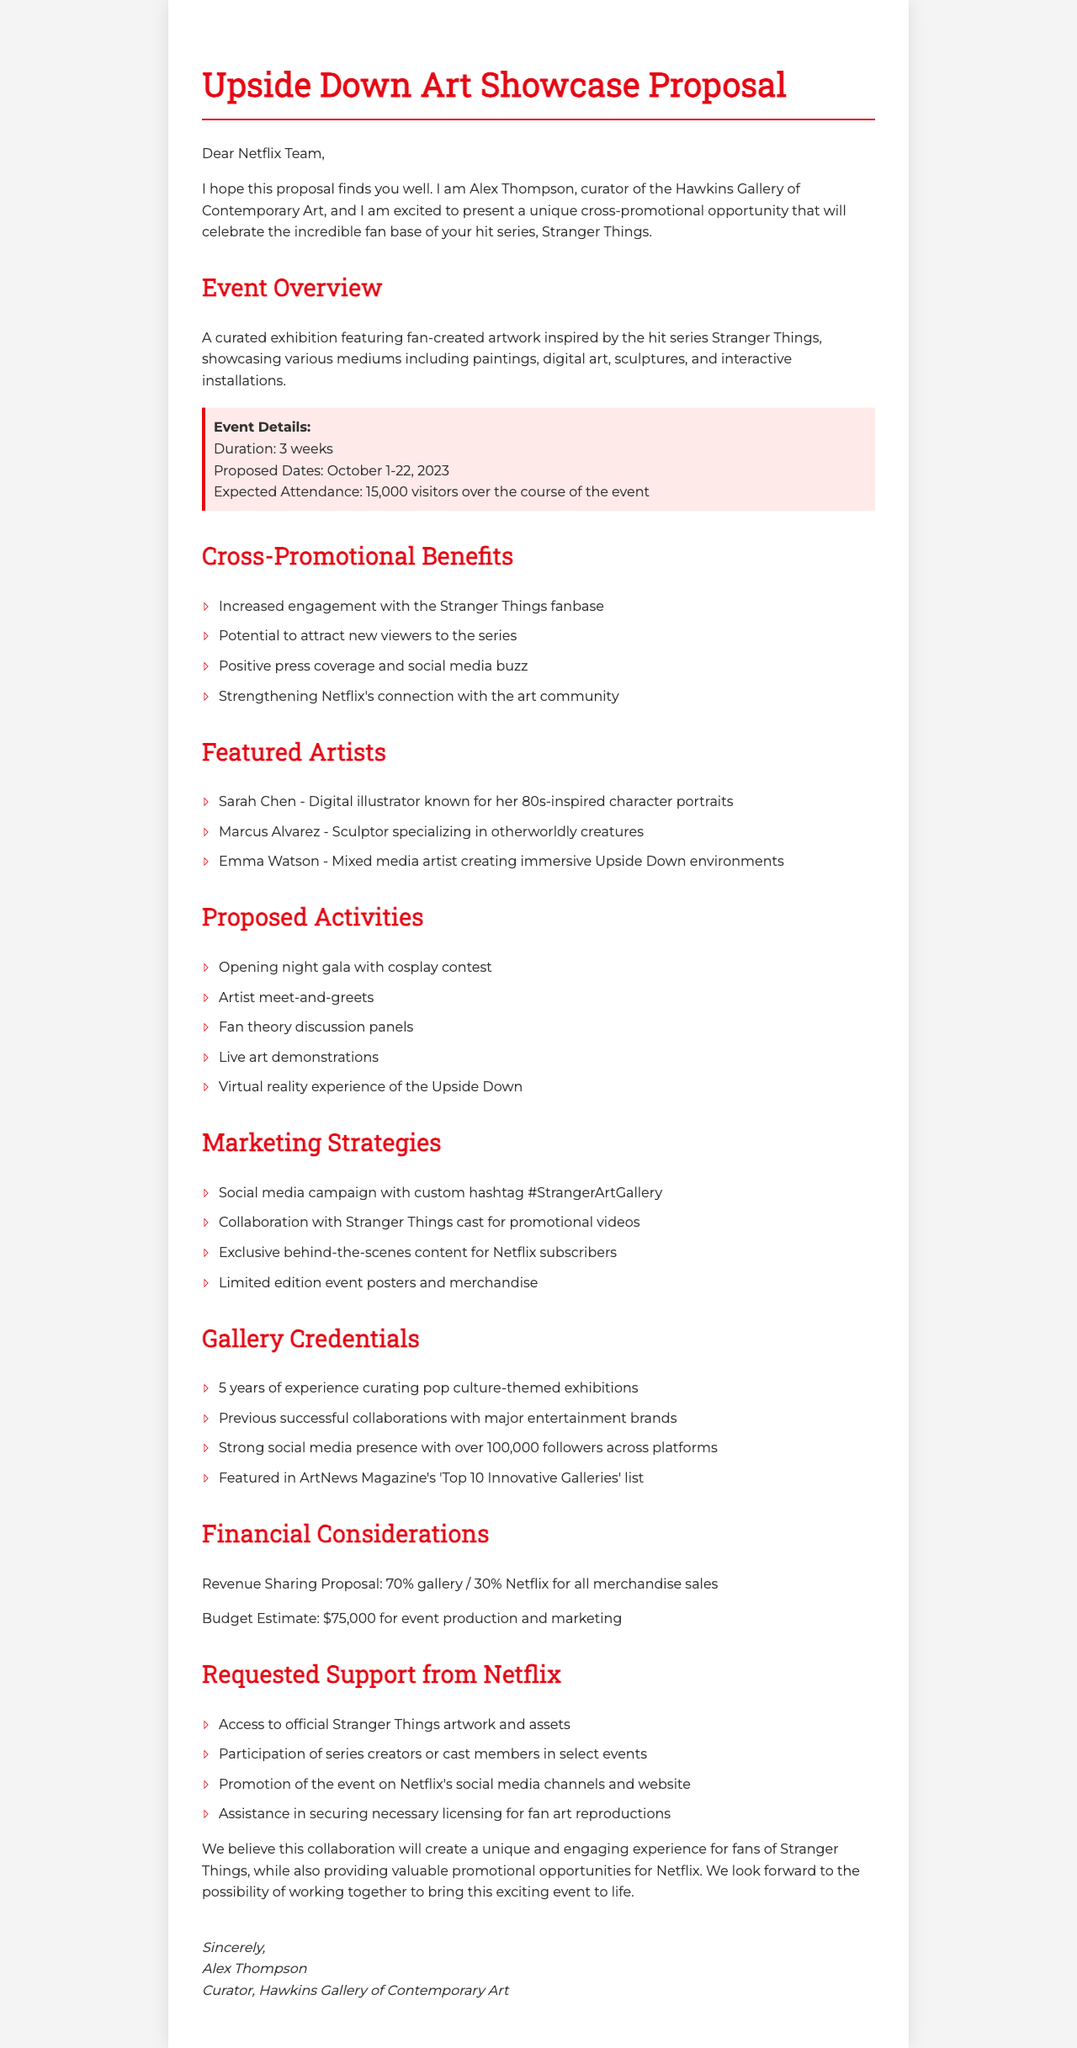What is the event name? The event name is explicitly mentioned in the document, which is "Upside Down Art Showcase".
Answer: Upside Down Art Showcase Who is the curator of the gallery? The document states the name of the curator as "Alex Thompson".
Answer: Alex Thompson What are the proposed dates for the event? The proposed dates are directly listed in the document as "October 1-22, 2023".
Answer: October 1-22, 2023 How many featured artists are mentioned? The discussion of featured artists indicates there are three specific artists listed in the document.
Answer: 3 What is the budget estimate for the event? The budget estimate is clearly specified in the document as "$75,000 for event production and marketing".
Answer: $75,000 What is the expected attendance for the event? The expected attendance figure is given in the document as "15,000 visitors over the course of the event".
Answer: 15,000 visitors What type of activities are proposed for the event? The document outlines several activities, one of which includes an "Opening night gala with cosplay contest".
Answer: Opening night gala with cosplay contest What is the revenue sharing proposal? The revenue sharing proposal is specified as "70% gallery / 30% Netflix for all merchandise sales".
Answer: 70% gallery / 30% Netflix What support is requested from Netflix? The document lists several forms of support requested, including "Access to official Stranger Things artwork and assets".
Answer: Access to official Stranger Things artwork and assets 